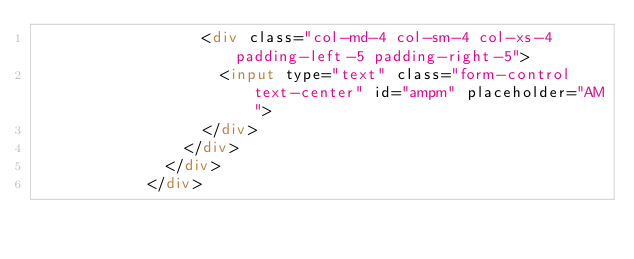Convert code to text. <code><loc_0><loc_0><loc_500><loc_500><_HTML_>                  <div class="col-md-4 col-sm-4 col-xs-4 padding-left-5 padding-right-5">
                    <input type="text" class="form-control text-center" id="ampm" placeholder="AM">
                  </div>
                </div>
              </div>
            </div></code> 